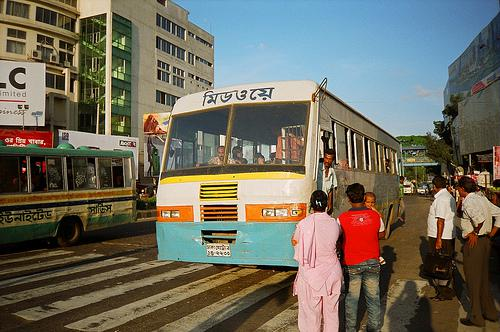Question: why are the people standing?
Choices:
A. To board the bus.
B. Waiting for the bus.
C. To play ball.
D. To fly kites.
Answer with the letter. Answer: B Question: who is wearing a red shirt?
Choices:
A. A man.
B. The woman.
C. The kid.
D. The biker.
Answer with the letter. Answer: A Question: what color is the woman's shirt?
Choices:
A. Teal.
B. Pink.
C. Orange.
D. Purple.
Answer with the letter. Answer: B Question: how many buses are there?
Choices:
A. Four.
B. Six.
C. Eight.
D. Two.
Answer with the letter. Answer: D Question: what is the sky like?
Choices:
A. Cloudy.
B. Rainy.
C. Dark.
D. Blue.
Answer with the letter. Answer: D Question: where is the woman standing?
Choices:
A. In front of the man.
B. Beside the kid.
C. On the sidewalk.
D. Next to the man in the red shirt.
Answer with the letter. Answer: D 